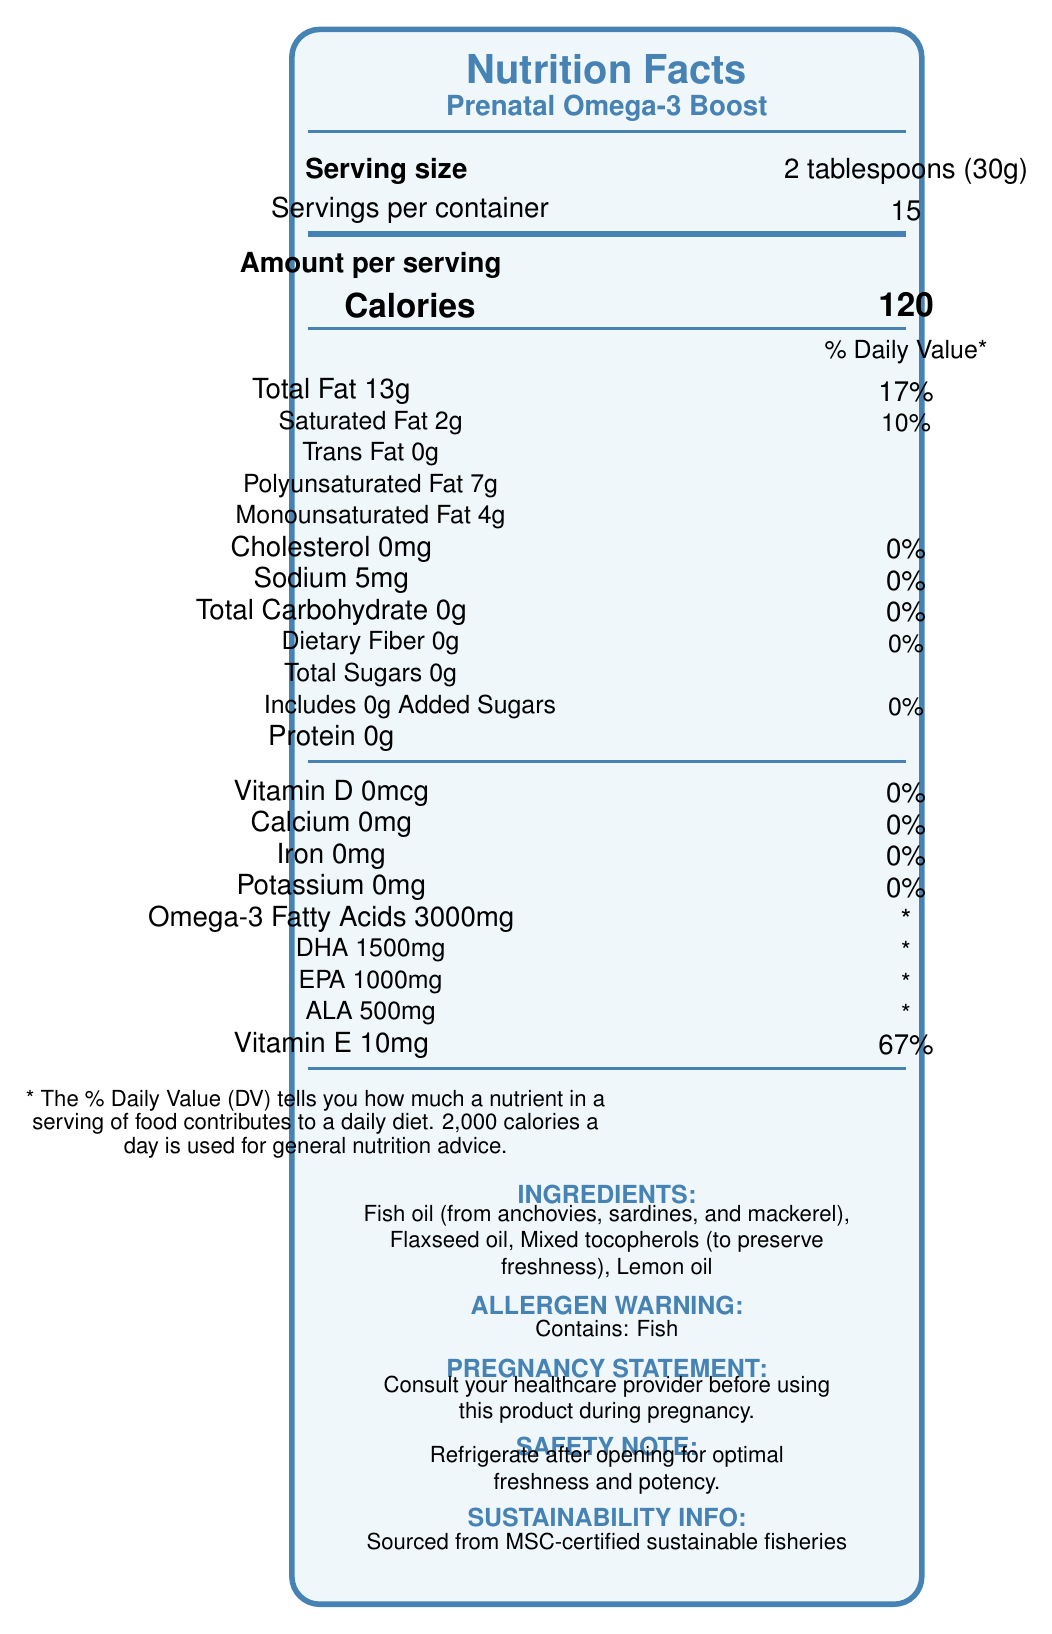what is the serving size for the Prenatal Omega-3 Boost? The serving size is clearly indicated in the document as "2 tablespoons (30g)" near the top of the Nutrition Facts section.
Answer: 2 tablespoons (30g) how many servings per container are there? This information is directly given in the document where it states "Servings per container: 15."
Answer: 15 what is the total amount of omega-3 fatty acids per serving? This amount is listed under the section titled "Omega-3 Fatty Acids."
Answer: 3000mg which vitamins and minerals have a daily value of 0%? The daily values for Vitamin D, Calcium, Iron, and Potassium are all listed as 0% in the document.
Answer: Vitamin D, Calcium, Iron, Potassium what is the daily value percentage for Vitamin E per serving? The document states that Vitamin E has a daily value of 67%.
Answer: 67% which ingredients are listed for the Prenatal Omega-3 Boost? A. Fish oil, Flaxseed oil, Mixed tocopherols, Lemon oil B. Fish oil, Soybean oil, Vitamin D, Lemon oil C. Flaxseed oil, Vitamin E, Fish oil, Lemon oil The correct ingredients listed are Fish oil, Flaxseed oil, Mixed tocopherols, and Lemon oil.
Answer: A. Fish oil, Flaxseed oil, Mixed tocopherols, Lemon oil how many calories are there per serving? 1. 100 2. 120 3. 150 4. 200 The document lists that each serving has 120 calories.
Answer: 2. 120 does this product contain any added sugars? The document shows "Includes 0g Added Sugars," indicating that there are no added sugars.
Answer: No is it recommended to consult a healthcare provider before using this product during pregnancy? The document includes a pregnancy statement that advises consulting a healthcare provider before using the product during pregnancy.
Answer: Yes summarize the main nutritional benefits of the Prenatal Omega-3 Boost. The document emphasizes the product's high omega-3 content, crucial for fetal brain and eye development, contributed by DHA, EPA, and ALA. It also notes the presence of Vitamin E as an antioxidant. It includes safety and pregnancy usage statements and highlights the sustainability of the ingredients.
Answer: The Prenatal Omega-3 Boost provides high levels of omega-3 fatty acids (DHA, EPA, and ALA), which are important for fetal brain and eye development. It also contains Vitamin E, acts as an antioxidant, and supports maternal health. Consult healthcare providers for optimal usage during pregnancy. what is the source of omega-3 in this product? The omega-3 is sourced from fish oil (anchovies, sardines, and mackerel) and flaxseed oil, as listed in the ingredients section.
Answer: Fish oil (from anchovies, sardines, and mackerel), Flaxseed oil how much DHA does one serving contain? According to the document, each serving contains 1500mg of DHA.
Answer: 1500mg what is the total fat content per serving? The document lists the total fat content as 13g per serving.
Answer: 13g what sustainability information is given about the product? The document indicates that the product is sourced from MSC-certified sustainable fisheries.
Answer: Sourced from MSC-certified sustainable fisheries is there any cholesterol in this product? The document specifies that the cholesterol amount is 0mg, indicating there is no cholesterol.
Answer: No what additional steps does the document suggest for maintaining the product's quality? The document contains a safety note that advises refrigerating the product after opening to maintain freshness and potency.
Answer: Refrigerate after opening for optimal freshness and potency. what is the percentage of polyunsaturated fat in the total fat content? The document provides the amounts of polyunsaturated fat and total fat, but it does not provide the percentage breakdown of polyunsaturated fat within the total fat content.
Answer: Cannot be determined 